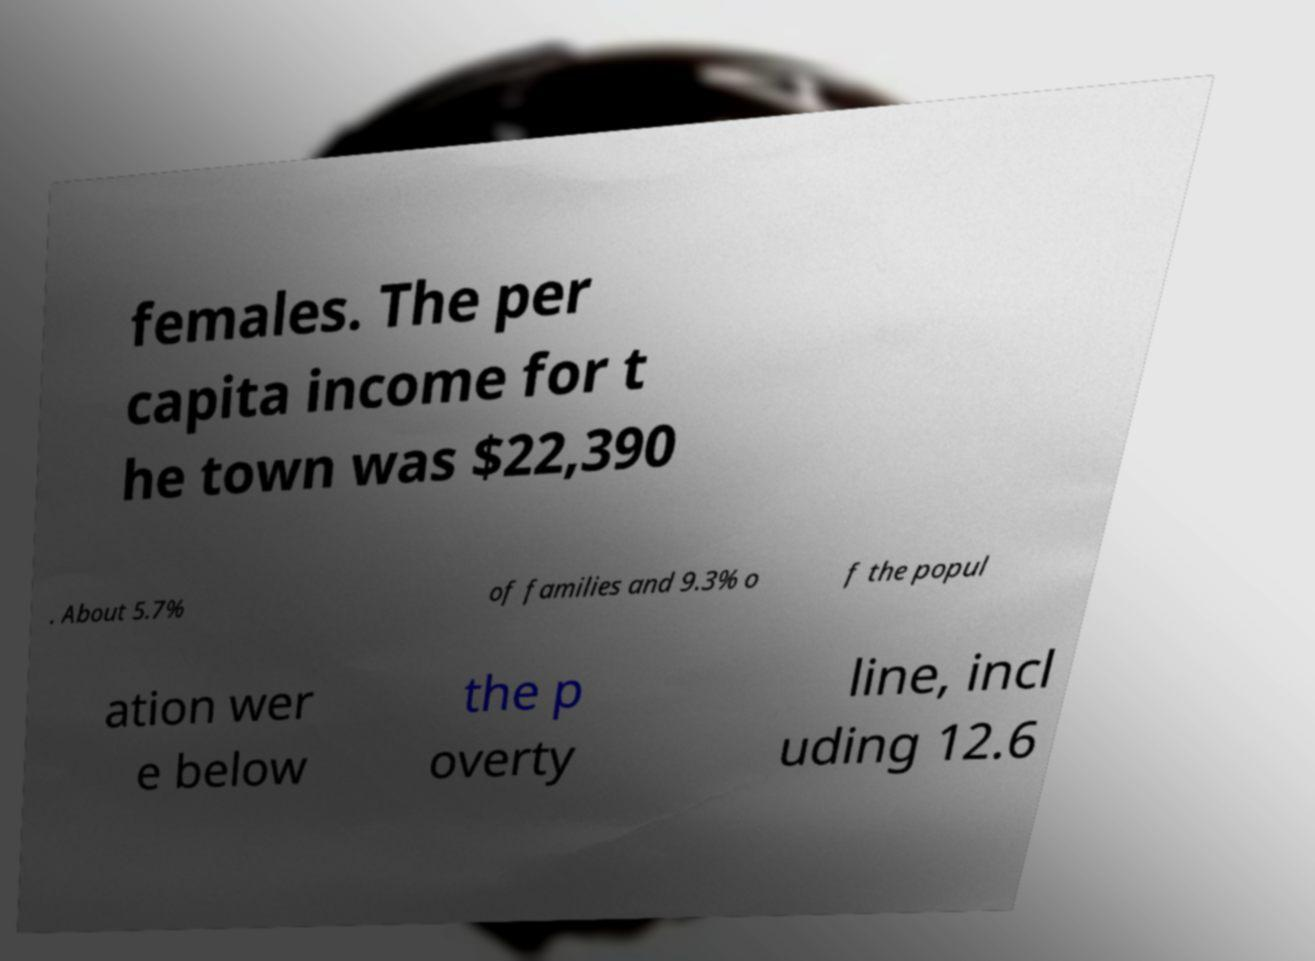Please identify and transcribe the text found in this image. females. The per capita income for t he town was $22,390 . About 5.7% of families and 9.3% o f the popul ation wer e below the p overty line, incl uding 12.6 